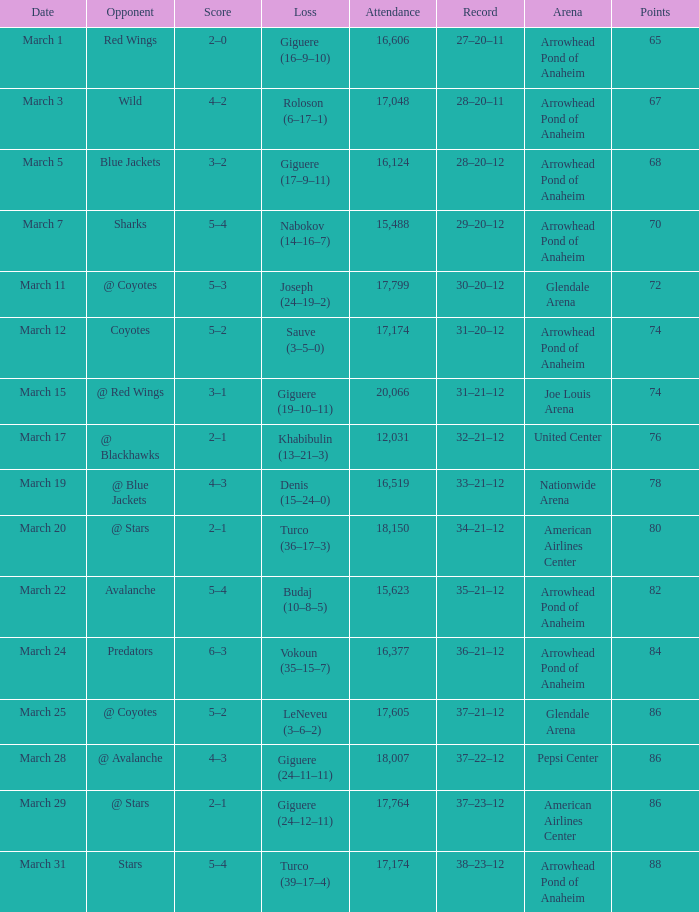What was the game's score on march 19? 4–3. 